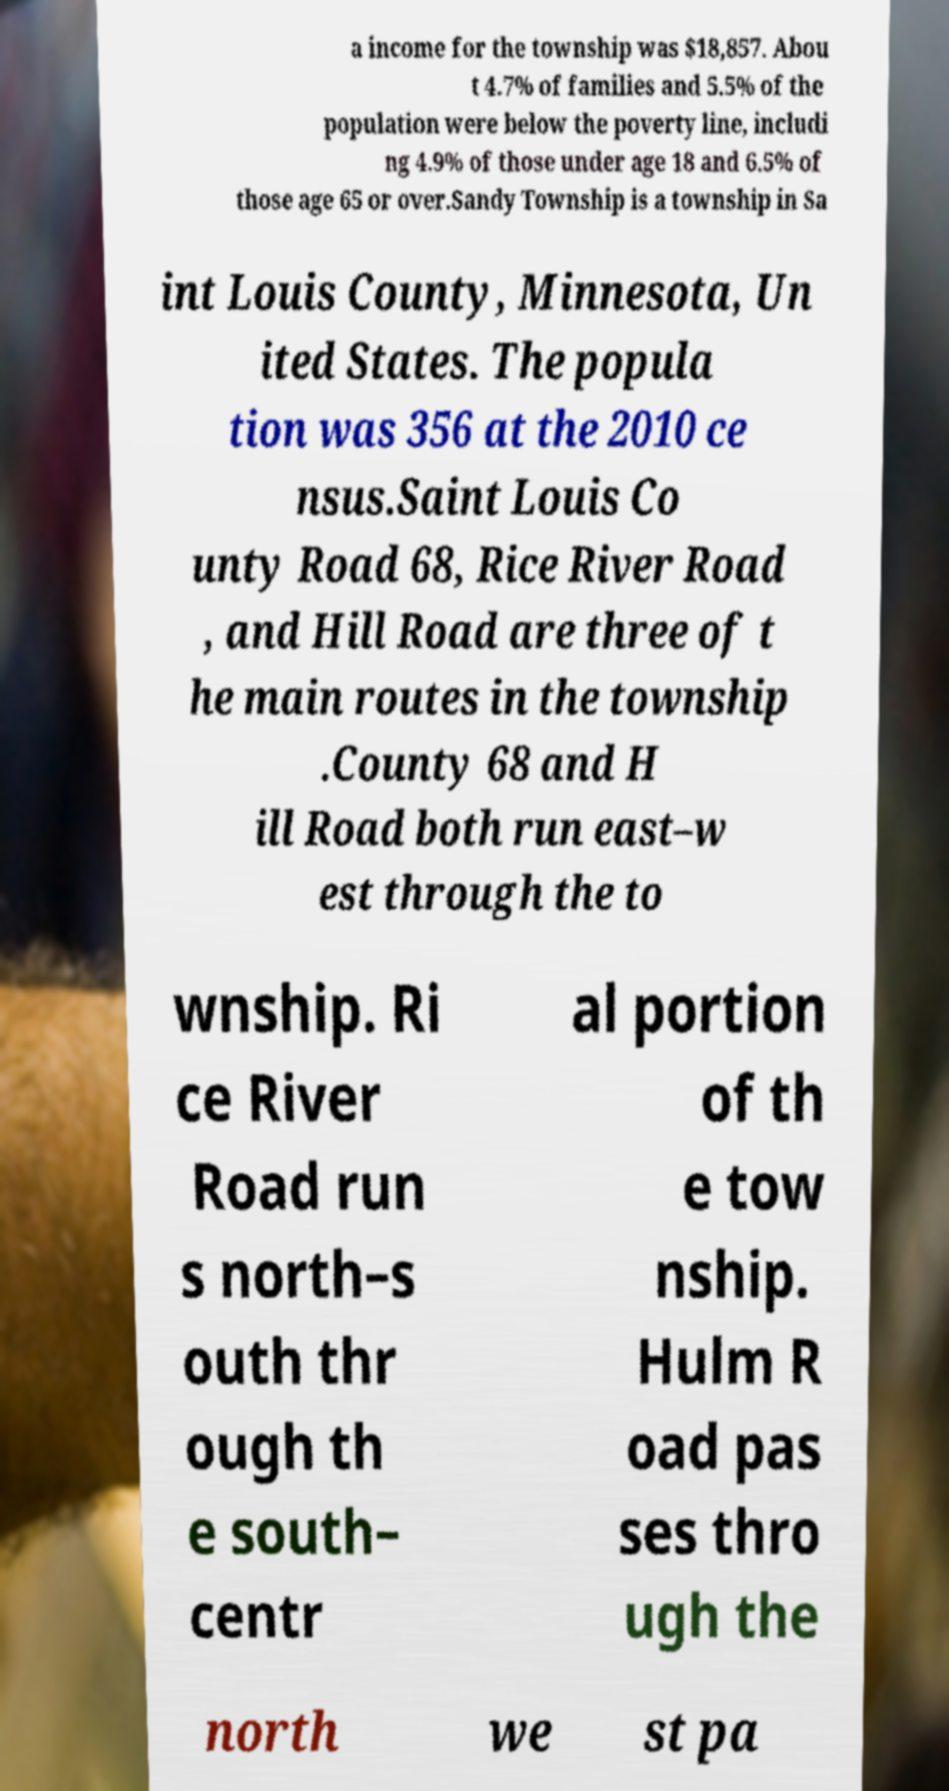Could you extract and type out the text from this image? a income for the township was $18,857. Abou t 4.7% of families and 5.5% of the population were below the poverty line, includi ng 4.9% of those under age 18 and 6.5% of those age 65 or over.Sandy Township is a township in Sa int Louis County, Minnesota, Un ited States. The popula tion was 356 at the 2010 ce nsus.Saint Louis Co unty Road 68, Rice River Road , and Hill Road are three of t he main routes in the township .County 68 and H ill Road both run east–w est through the to wnship. Ri ce River Road run s north–s outh thr ough th e south– centr al portion of th e tow nship. Hulm R oad pas ses thro ugh the north we st pa 